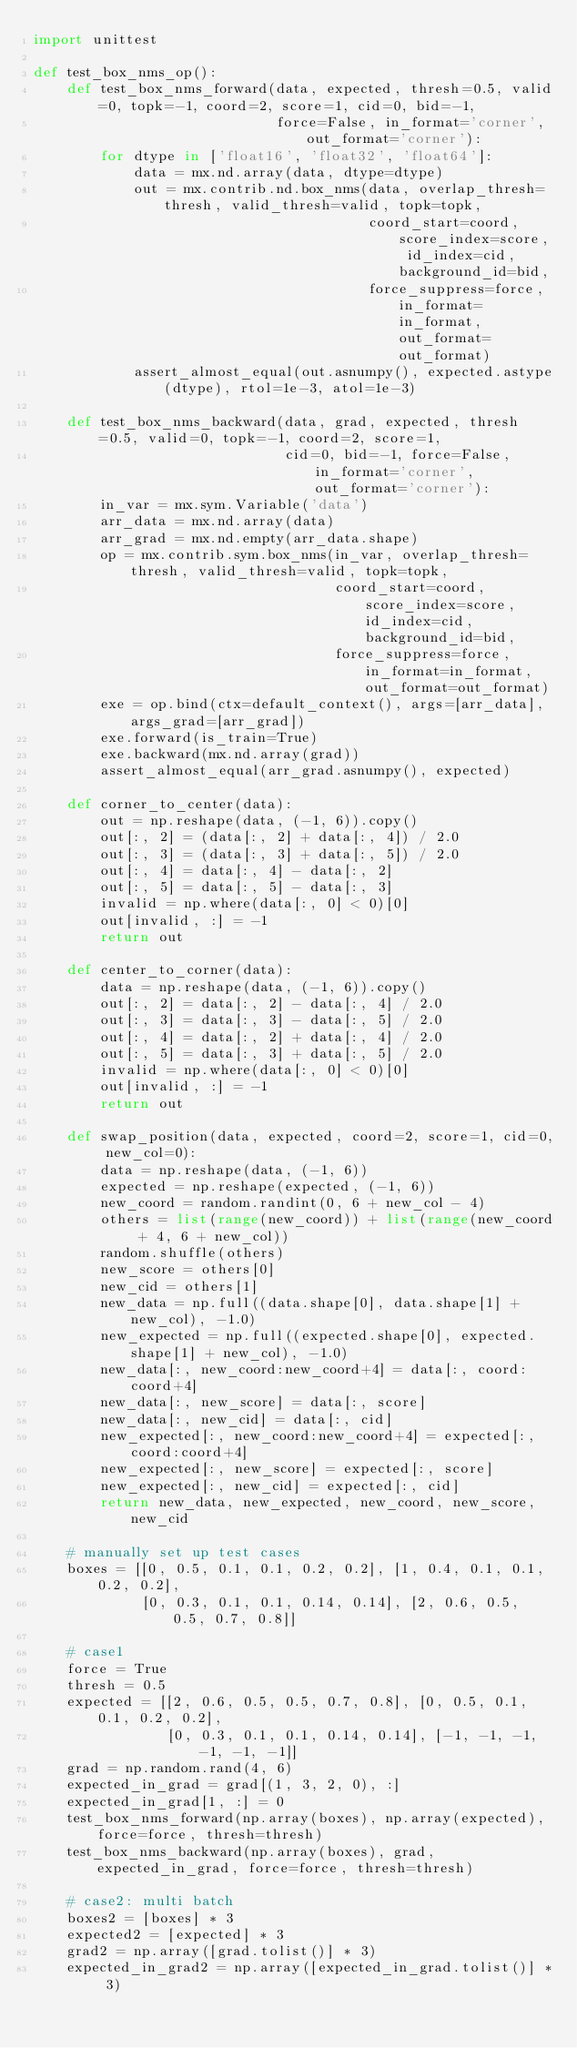<code> <loc_0><loc_0><loc_500><loc_500><_Python_>import unittest

def test_box_nms_op():
    def test_box_nms_forward(data, expected, thresh=0.5, valid=0, topk=-1, coord=2, score=1, cid=0, bid=-1,
                             force=False, in_format='corner', out_format='corner'):
        for dtype in ['float16', 'float32', 'float64']:
            data = mx.nd.array(data, dtype=dtype)
            out = mx.contrib.nd.box_nms(data, overlap_thresh=thresh, valid_thresh=valid, topk=topk,
                                        coord_start=coord, score_index=score, id_index=cid, background_id=bid,
                                        force_suppress=force, in_format=in_format, out_format=out_format)
            assert_almost_equal(out.asnumpy(), expected.astype(dtype), rtol=1e-3, atol=1e-3)

    def test_box_nms_backward(data, grad, expected, thresh=0.5, valid=0, topk=-1, coord=2, score=1,
                              cid=0, bid=-1, force=False, in_format='corner', out_format='corner'):
        in_var = mx.sym.Variable('data')
        arr_data = mx.nd.array(data)
        arr_grad = mx.nd.empty(arr_data.shape)
        op = mx.contrib.sym.box_nms(in_var, overlap_thresh=thresh, valid_thresh=valid, topk=topk,
                                    coord_start=coord, score_index=score, id_index=cid, background_id=bid,
                                    force_suppress=force, in_format=in_format, out_format=out_format)
        exe = op.bind(ctx=default_context(), args=[arr_data], args_grad=[arr_grad])
        exe.forward(is_train=True)
        exe.backward(mx.nd.array(grad))
        assert_almost_equal(arr_grad.asnumpy(), expected)

    def corner_to_center(data):
        out = np.reshape(data, (-1, 6)).copy()
        out[:, 2] = (data[:, 2] + data[:, 4]) / 2.0
        out[:, 3] = (data[:, 3] + data[:, 5]) / 2.0
        out[:, 4] = data[:, 4] - data[:, 2]
        out[:, 5] = data[:, 5] - data[:, 3]
        invalid = np.where(data[:, 0] < 0)[0]
        out[invalid, :] = -1
        return out

    def center_to_corner(data):
        data = np.reshape(data, (-1, 6)).copy()
        out[:, 2] = data[:, 2] - data[:, 4] / 2.0
        out[:, 3] = data[:, 3] - data[:, 5] / 2.0
        out[:, 4] = data[:, 2] + data[:, 4] / 2.0
        out[:, 5] = data[:, 3] + data[:, 5] / 2.0
        invalid = np.where(data[:, 0] < 0)[0]
        out[invalid, :] = -1
        return out

    def swap_position(data, expected, coord=2, score=1, cid=0, new_col=0):
        data = np.reshape(data, (-1, 6))
        expected = np.reshape(expected, (-1, 6))
        new_coord = random.randint(0, 6 + new_col - 4)
        others = list(range(new_coord)) + list(range(new_coord + 4, 6 + new_col))
        random.shuffle(others)
        new_score = others[0]
        new_cid = others[1]
        new_data = np.full((data.shape[0], data.shape[1] + new_col), -1.0)
        new_expected = np.full((expected.shape[0], expected.shape[1] + new_col), -1.0)
        new_data[:, new_coord:new_coord+4] = data[:, coord:coord+4]
        new_data[:, new_score] = data[:, score]
        new_data[:, new_cid] = data[:, cid]
        new_expected[:, new_coord:new_coord+4] = expected[:, coord:coord+4]
        new_expected[:, new_score] = expected[:, score]
        new_expected[:, new_cid] = expected[:, cid]
        return new_data, new_expected, new_coord, new_score, new_cid

    # manually set up test cases
    boxes = [[0, 0.5, 0.1, 0.1, 0.2, 0.2], [1, 0.4, 0.1, 0.1, 0.2, 0.2],
             [0, 0.3, 0.1, 0.1, 0.14, 0.14], [2, 0.6, 0.5, 0.5, 0.7, 0.8]]

    # case1
    force = True
    thresh = 0.5
    expected = [[2, 0.6, 0.5, 0.5, 0.7, 0.8], [0, 0.5, 0.1, 0.1, 0.2, 0.2],
                [0, 0.3, 0.1, 0.1, 0.14, 0.14], [-1, -1, -1, -1, -1, -1]]
    grad = np.random.rand(4, 6)
    expected_in_grad = grad[(1, 3, 2, 0), :]
    expected_in_grad[1, :] = 0
    test_box_nms_forward(np.array(boxes), np.array(expected), force=force, thresh=thresh)
    test_box_nms_backward(np.array(boxes), grad, expected_in_grad, force=force, thresh=thresh)

    # case2: multi batch
    boxes2 = [boxes] * 3
    expected2 = [expected] * 3
    grad2 = np.array([grad.tolist()] * 3)
    expected_in_grad2 = np.array([expected_in_grad.tolist()] * 3)</code> 